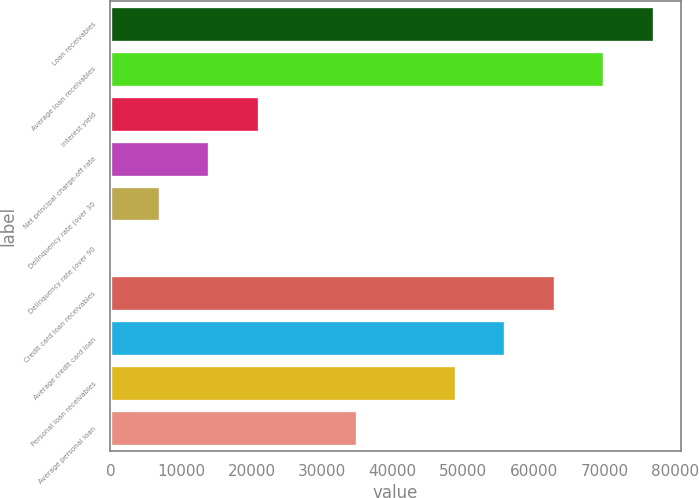Convert chart to OTSL. <chart><loc_0><loc_0><loc_500><loc_500><bar_chart><fcel>Loan receivables<fcel>Average loan receivables<fcel>Interest yield<fcel>Net principal charge-off rate<fcel>Delinquency rate (over 30<fcel>Delinquency rate (over 90<fcel>Credit card loan receivables<fcel>Average credit card loan<fcel>Personal loan receivables<fcel>Average personal loan<nl><fcel>76965.8<fcel>69969<fcel>20991.2<fcel>13994.4<fcel>6997.6<fcel>0.78<fcel>62972.2<fcel>55975.3<fcel>48978.5<fcel>34984.9<nl></chart> 